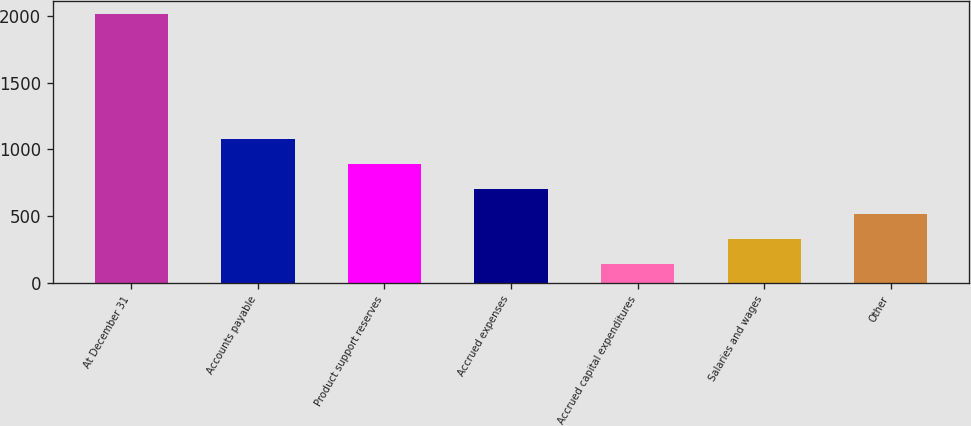Convert chart. <chart><loc_0><loc_0><loc_500><loc_500><bar_chart><fcel>At December 31<fcel>Accounts payable<fcel>Product support reserves<fcel>Accrued expenses<fcel>Accrued capital expenditures<fcel>Salaries and wages<fcel>Other<nl><fcel>2013<fcel>1076.45<fcel>889.14<fcel>701.83<fcel>139.9<fcel>327.21<fcel>514.52<nl></chart> 